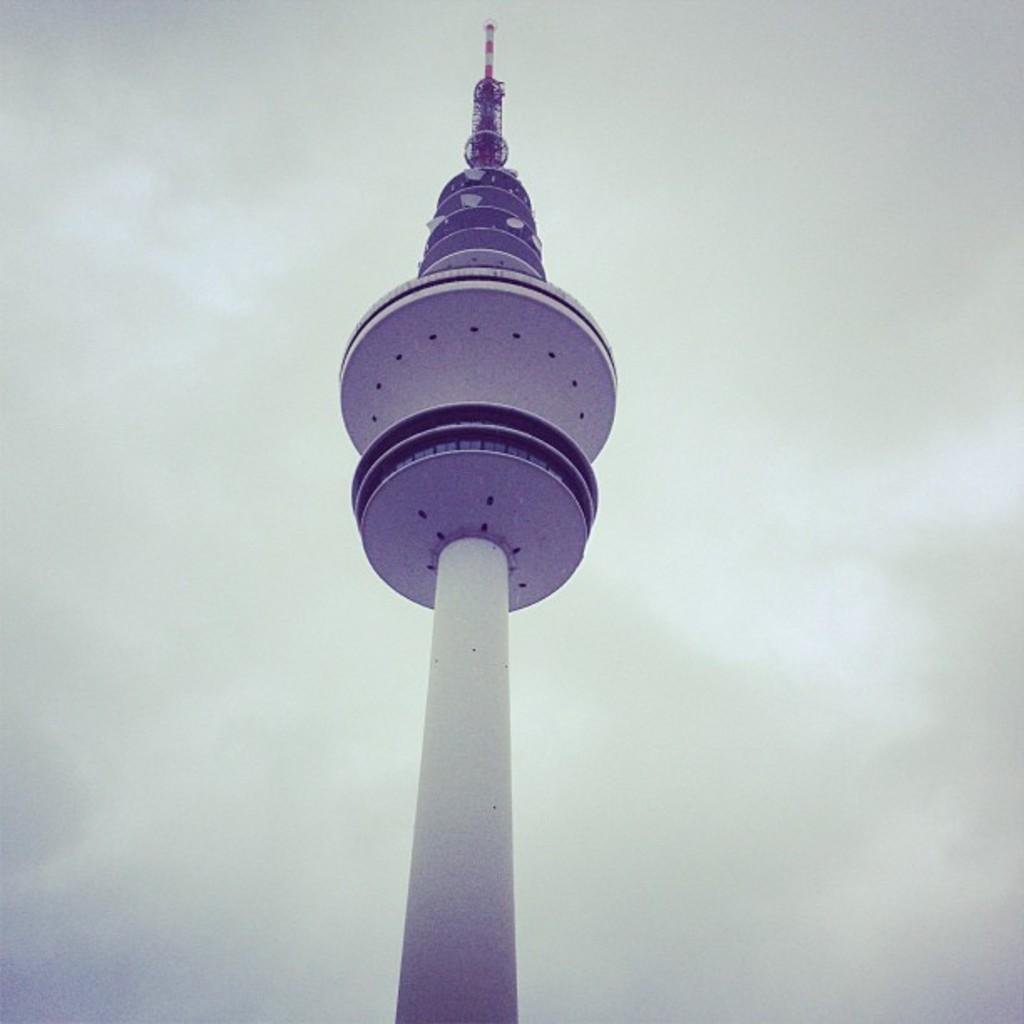Could you give a brief overview of what you see in this image? In this image, I can see a tower. In the background, there is the sky. 